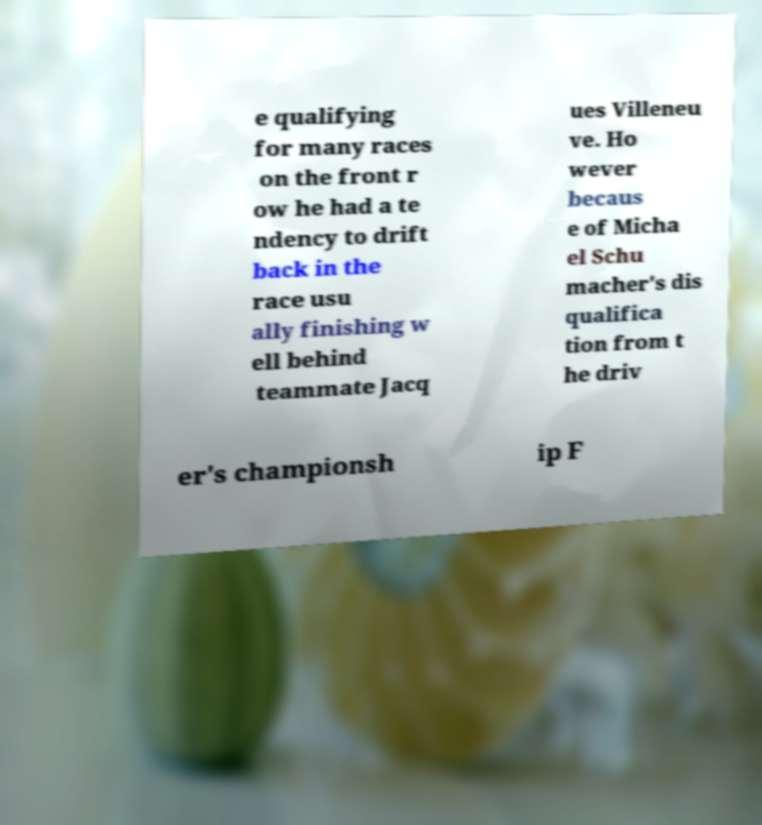What messages or text are displayed in this image? I need them in a readable, typed format. e qualifying for many races on the front r ow he had a te ndency to drift back in the race usu ally finishing w ell behind teammate Jacq ues Villeneu ve. Ho wever becaus e of Micha el Schu macher's dis qualifica tion from t he driv er's championsh ip F 